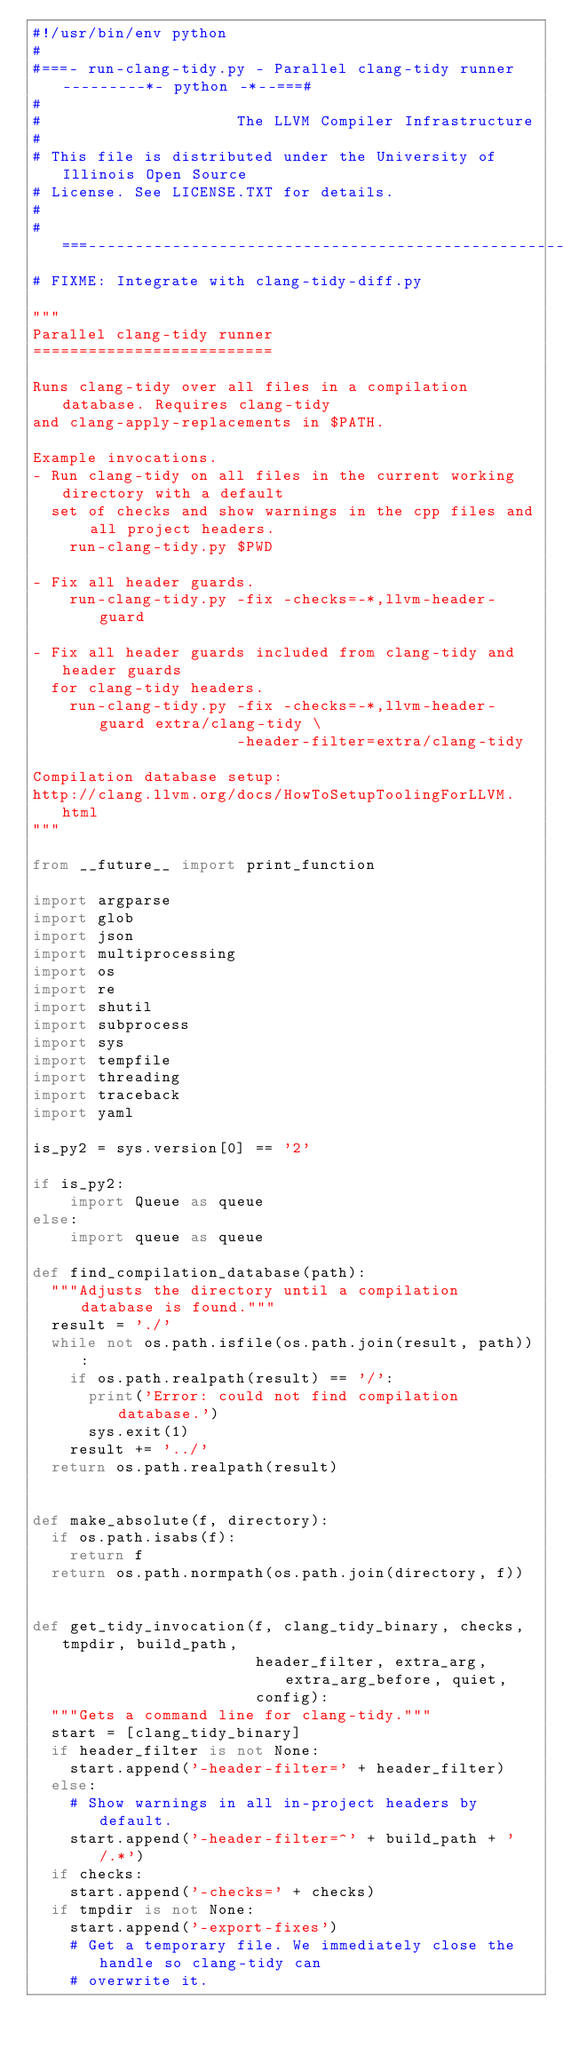<code> <loc_0><loc_0><loc_500><loc_500><_Python_>#!/usr/bin/env python
#
#===- run-clang-tidy.py - Parallel clang-tidy runner ---------*- python -*--===#
#
#                     The LLVM Compiler Infrastructure
#
# This file is distributed under the University of Illinois Open Source
# License. See LICENSE.TXT for details.
#
#===------------------------------------------------------------------------===#
# FIXME: Integrate with clang-tidy-diff.py

"""
Parallel clang-tidy runner
==========================

Runs clang-tidy over all files in a compilation database. Requires clang-tidy
and clang-apply-replacements in $PATH.

Example invocations.
- Run clang-tidy on all files in the current working directory with a default
  set of checks and show warnings in the cpp files and all project headers.
    run-clang-tidy.py $PWD

- Fix all header guards.
    run-clang-tidy.py -fix -checks=-*,llvm-header-guard

- Fix all header guards included from clang-tidy and header guards
  for clang-tidy headers.
    run-clang-tidy.py -fix -checks=-*,llvm-header-guard extra/clang-tidy \
                      -header-filter=extra/clang-tidy

Compilation database setup:
http://clang.llvm.org/docs/HowToSetupToolingForLLVM.html
"""

from __future__ import print_function

import argparse
import glob
import json
import multiprocessing
import os
import re
import shutil
import subprocess
import sys
import tempfile
import threading
import traceback
import yaml

is_py2 = sys.version[0] == '2'

if is_py2:
    import Queue as queue
else:
    import queue as queue

def find_compilation_database(path):
  """Adjusts the directory until a compilation database is found."""
  result = './'
  while not os.path.isfile(os.path.join(result, path)):
    if os.path.realpath(result) == '/':
      print('Error: could not find compilation database.')
      sys.exit(1)
    result += '../'
  return os.path.realpath(result)


def make_absolute(f, directory):
  if os.path.isabs(f):
    return f
  return os.path.normpath(os.path.join(directory, f))


def get_tidy_invocation(f, clang_tidy_binary, checks, tmpdir, build_path,
                        header_filter, extra_arg, extra_arg_before, quiet,
                        config):
  """Gets a command line for clang-tidy."""
  start = [clang_tidy_binary]
  if header_filter is not None:
    start.append('-header-filter=' + header_filter)
  else:
    # Show warnings in all in-project headers by default.
    start.append('-header-filter=^' + build_path + '/.*')
  if checks:
    start.append('-checks=' + checks)
  if tmpdir is not None:
    start.append('-export-fixes')
    # Get a temporary file. We immediately close the handle so clang-tidy can
    # overwrite it.</code> 